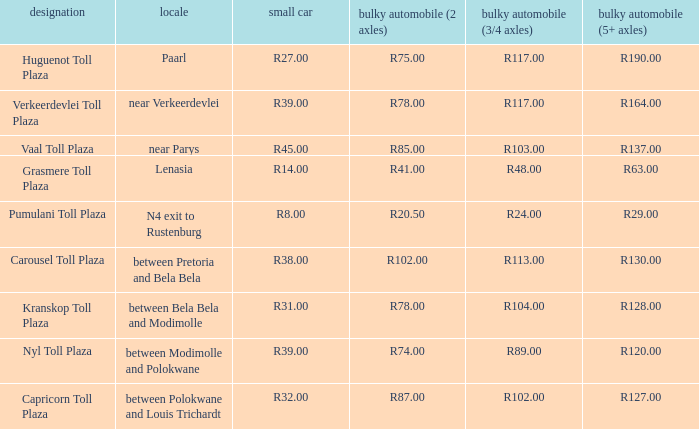What is the name of the plaza where the told for heavy vehicles with 2 axles is r20.50? Pumulani Toll Plaza. 